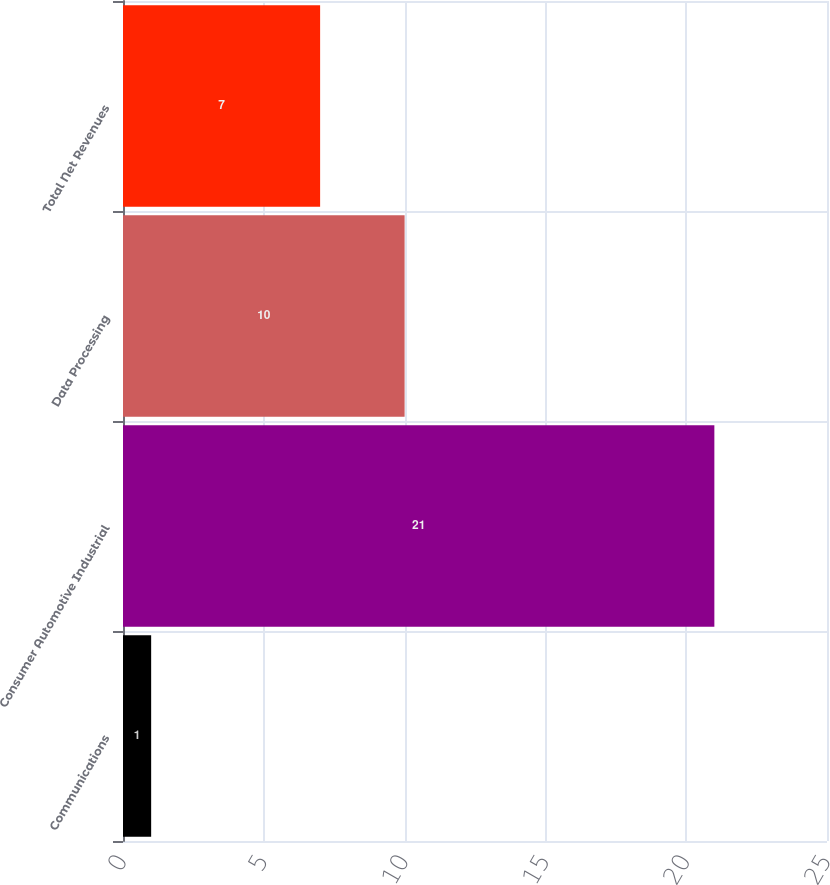Convert chart. <chart><loc_0><loc_0><loc_500><loc_500><bar_chart><fcel>Communications<fcel>Consumer Automotive Industrial<fcel>Data Processing<fcel>Total Net Revenues<nl><fcel>1<fcel>21<fcel>10<fcel>7<nl></chart> 